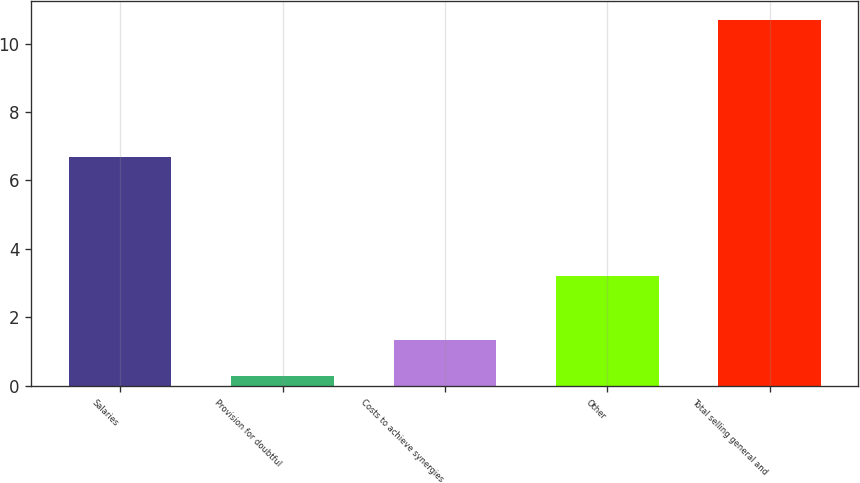Convert chart to OTSL. <chart><loc_0><loc_0><loc_500><loc_500><bar_chart><fcel>Salaries<fcel>Provision for doubtful<fcel>Costs to achieve synergies<fcel>Other<fcel>Total selling general and<nl><fcel>6.7<fcel>0.3<fcel>1.34<fcel>3.2<fcel>10.7<nl></chart> 